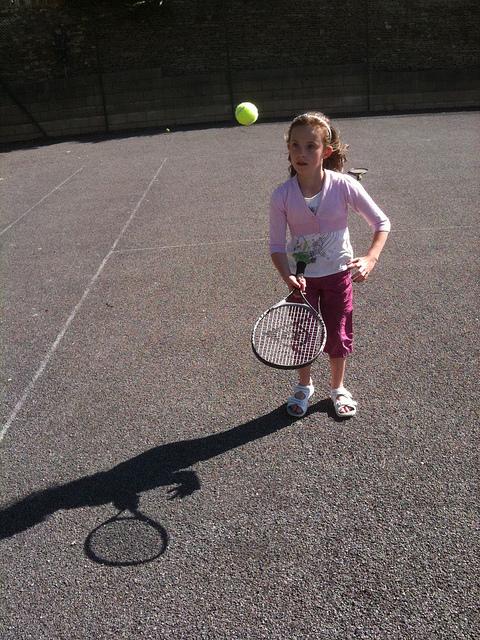What hair accessory is in the girl's hair?
Answer briefly. Headband. How many balls are visible?
Quick response, please. 1. What game is the girl playing?
Answer briefly. Tennis. What is the color of the girls pants?
Answer briefly. Pink. 